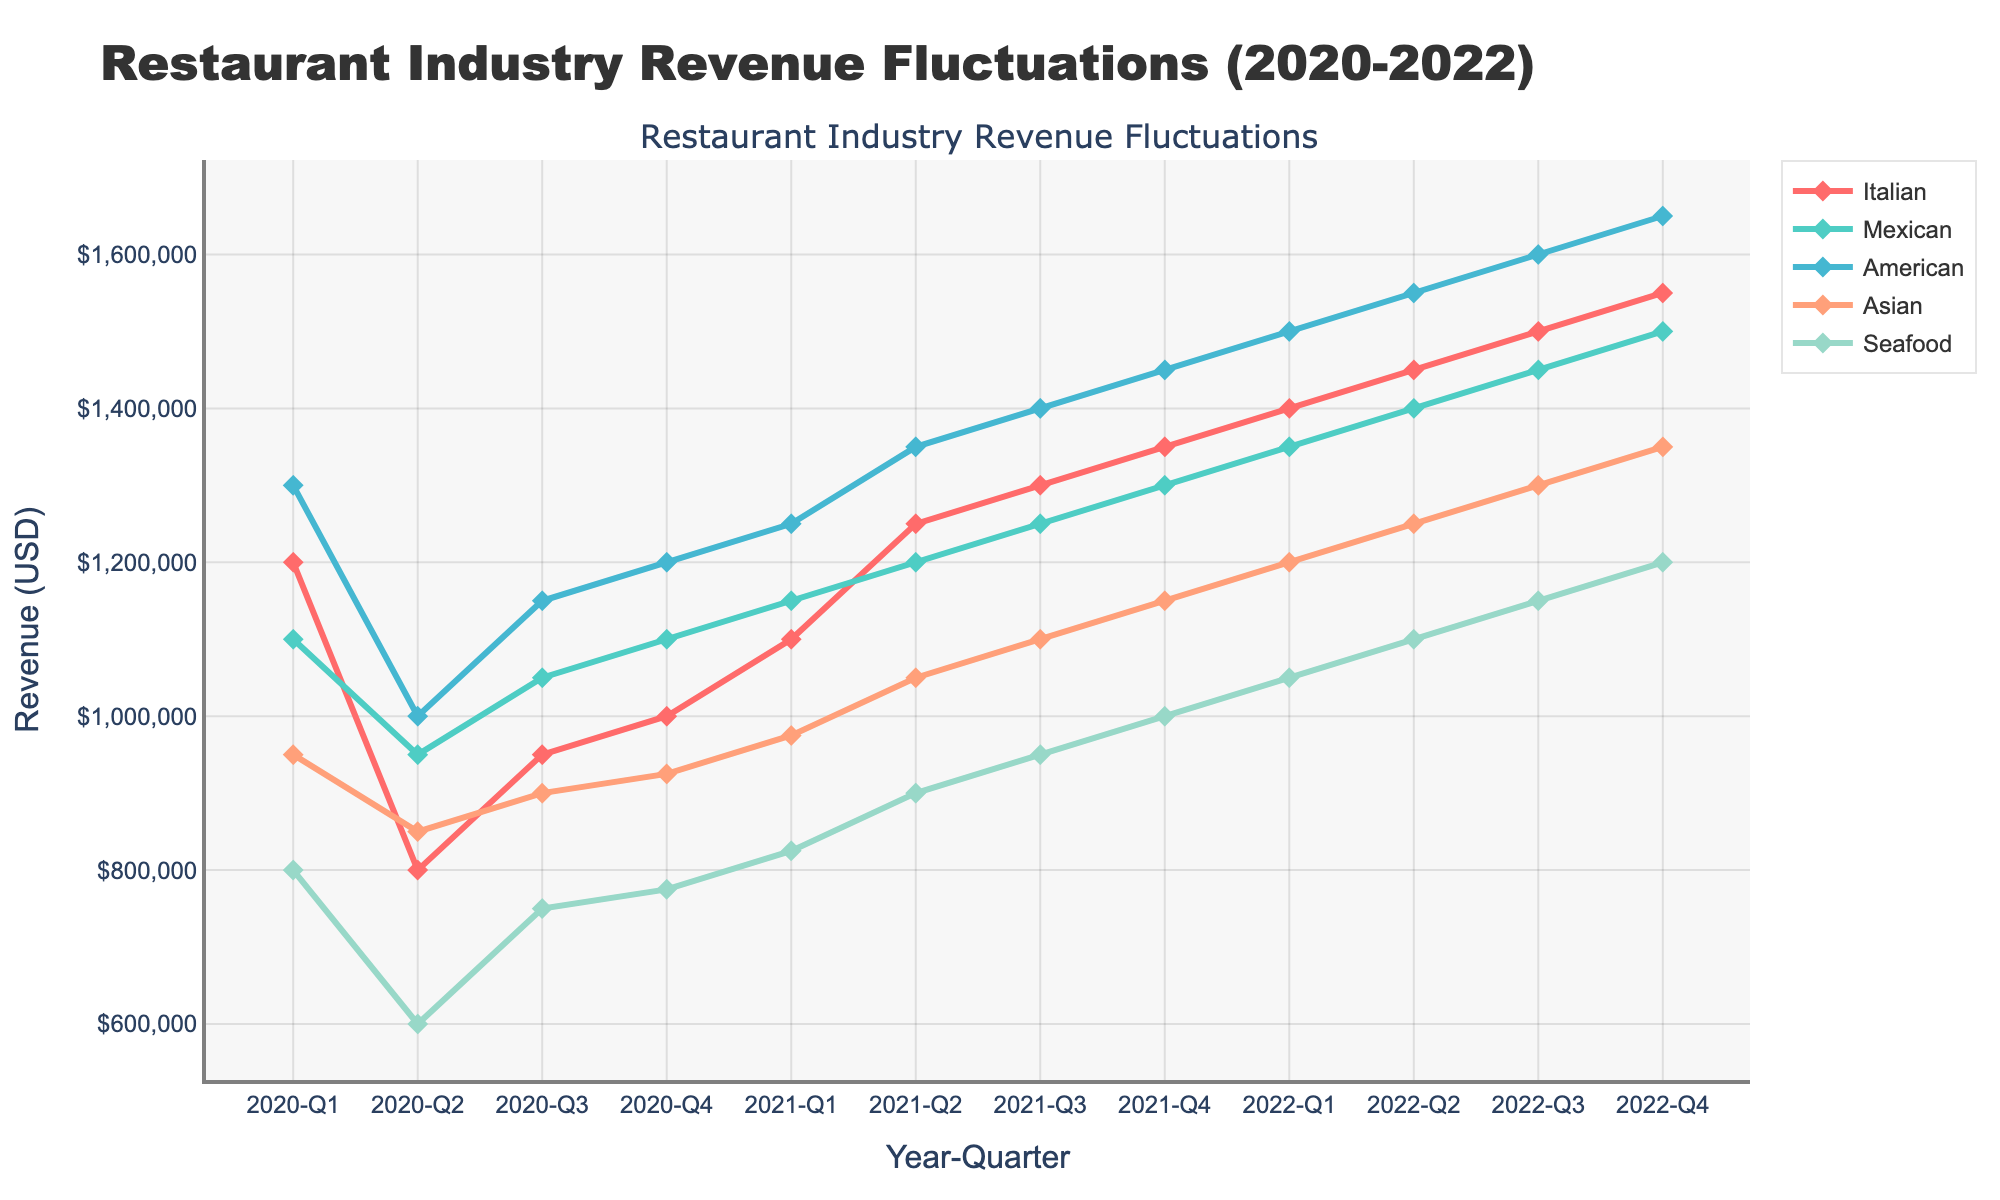Which cuisine had the highest revenue in 2022-Q4? To determine the cuisine with the highest revenue in the last quarter, look at the endpoint of each line in 2022-Q4. The American cuisine revenue is highest among the markers.
Answer: American What was the total revenue for Seafood cuisine in 2021? Add up the revenues for Seafood cuisine for all the quarters in 2021: 825000 (Q1) + 900000 (Q2) + 950000 (Q3) + 1000000 (Q4) = 3675000.
Answer: 3675000 How much did Mexican cuisine grow from 2020-Q1 to 2022-Q4? Subtract the revenue of Mexican cuisine in 2020-Q1 from that in 2022-Q4: 1500000 - 1100000 = 450000.
Answer: 450000 Which quarter had the lowest revenue for Asian cuisine? Identify the lowest point on the line representing Asian cuisine. The lowest revenue is at 2020-Q2 with 850000.
Answer: 2020-Q2 What is the average quarterly revenue for Italian cuisine in 2021? Sum the quarterly revenues for Italian cuisine in 2021 and divide by the number of quarters: (1100000 + 1250000 + 1300000 + 1350000) / 4 = 1250000.
Answer: 1250000 By how much did American cuisine outperform Asian cuisine in 2021-Q2? Subtract the revenue of Asian cuisine from American cuisine in 2021-Q2: 1350000 - 1050000 = 300000.
Answer: 300000 Which cuisine had a steady increase in revenue every quarter from 2020-Q2 to 2022-Q4? Observe the trend lines for each cuisine and identify the one that consistently increases without fluctuation, which is Italian cuisine.
Answer: Italian In which quarter did the Seafood cuisine revenue first exceed 1 million USD? Check each quarter’s revenue for Seafood cuisine and identify the first instance where it surpasses 1000000, which is 2022-Q2 with 1100000.
Answer: 2022-Q2 What is the revenue difference between the highest and lowest revenue quarters for Mexican cuisine? Mexican cuisine's highest revenue is in 2022-Q4 (1500000) and the lowest is in 2020-Q2 (950000). The difference is 1500000 - 950000 = 550000.
Answer: 550000 